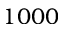Convert formula to latex. <formula><loc_0><loc_0><loc_500><loc_500>1 0 0 0</formula> 